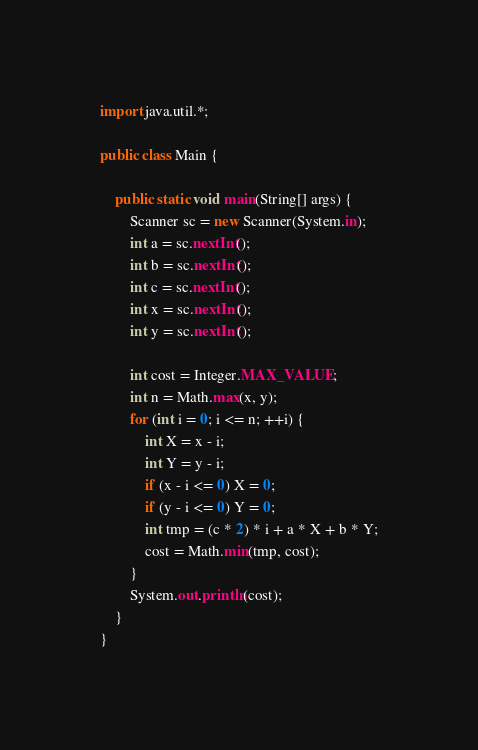Convert code to text. <code><loc_0><loc_0><loc_500><loc_500><_Java_>import java.util.*;

public class Main {

    public static void main(String[] args) {
        Scanner sc = new Scanner(System.in);
        int a = sc.nextInt();
        int b = sc.nextInt();
        int c = sc.nextInt();
        int x = sc.nextInt();
        int y = sc.nextInt();

        int cost = Integer.MAX_VALUE;
        int n = Math.max(x, y);
        for (int i = 0; i <= n; ++i) {
            int X = x - i;
            int Y = y - i;
            if (x - i <= 0) X = 0;
            if (y - i <= 0) Y = 0;
            int tmp = (c * 2) * i + a * X + b * Y;
            cost = Math.min(tmp, cost);
        }
        System.out.println(cost);
    }
}</code> 